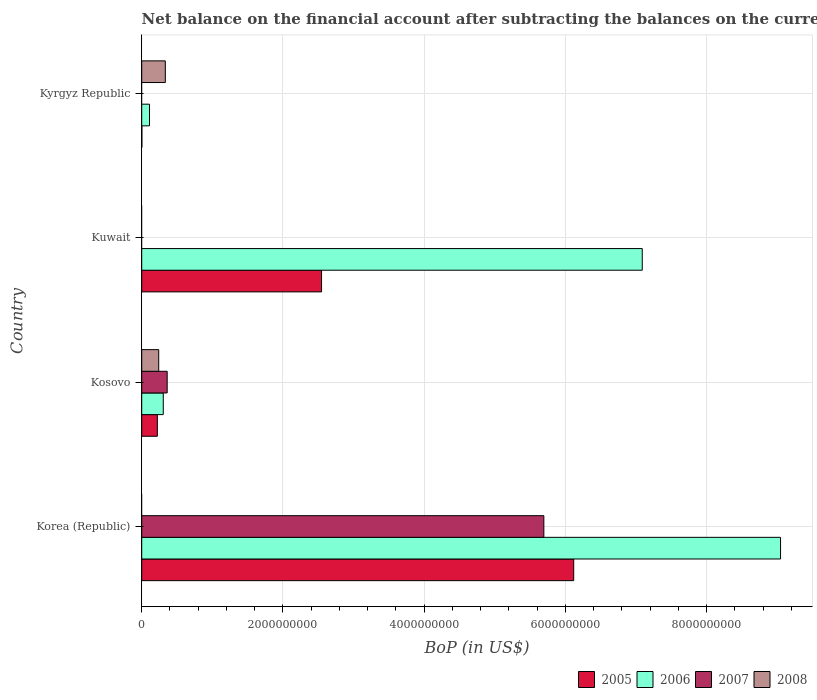Are the number of bars on each tick of the Y-axis equal?
Give a very brief answer. No. How many bars are there on the 3rd tick from the top?
Provide a succinct answer. 4. How many bars are there on the 4th tick from the bottom?
Make the answer very short. 3. What is the label of the 2nd group of bars from the top?
Your response must be concise. Kuwait. In how many cases, is the number of bars for a given country not equal to the number of legend labels?
Provide a succinct answer. 3. Across all countries, what is the maximum Balance of Payments in 2006?
Make the answer very short. 9.05e+09. What is the total Balance of Payments in 2006 in the graph?
Your answer should be compact. 1.65e+1. What is the difference between the Balance of Payments in 2007 in Korea (Republic) and that in Kosovo?
Make the answer very short. 5.33e+09. What is the difference between the Balance of Payments in 2005 in Kosovo and the Balance of Payments in 2006 in Kyrgyz Republic?
Give a very brief answer. 1.11e+08. What is the average Balance of Payments in 2007 per country?
Give a very brief answer. 1.51e+09. What is the difference between the Balance of Payments in 2005 and Balance of Payments in 2007 in Korea (Republic)?
Provide a short and direct response. 4.23e+08. In how many countries, is the Balance of Payments in 2006 greater than 4000000000 US$?
Keep it short and to the point. 2. What is the ratio of the Balance of Payments in 2005 in Kuwait to that in Kyrgyz Republic?
Ensure brevity in your answer.  1201.81. Is the Balance of Payments in 2005 in Kosovo less than that in Kuwait?
Your response must be concise. Yes. What is the difference between the highest and the second highest Balance of Payments in 2006?
Your answer should be very brief. 1.96e+09. What is the difference between the highest and the lowest Balance of Payments in 2005?
Keep it short and to the point. 6.11e+09. How many countries are there in the graph?
Your answer should be compact. 4. Are the values on the major ticks of X-axis written in scientific E-notation?
Keep it short and to the point. No. Does the graph contain any zero values?
Provide a short and direct response. Yes. What is the title of the graph?
Ensure brevity in your answer.  Net balance on the financial account after subtracting the balances on the current accounts. What is the label or title of the X-axis?
Your response must be concise. BoP (in US$). What is the BoP (in US$) of 2005 in Korea (Republic)?
Provide a succinct answer. 6.12e+09. What is the BoP (in US$) of 2006 in Korea (Republic)?
Provide a short and direct response. 9.05e+09. What is the BoP (in US$) in 2007 in Korea (Republic)?
Give a very brief answer. 5.69e+09. What is the BoP (in US$) in 2005 in Kosovo?
Your response must be concise. 2.21e+08. What is the BoP (in US$) of 2006 in Kosovo?
Make the answer very short. 3.05e+08. What is the BoP (in US$) in 2007 in Kosovo?
Your answer should be very brief. 3.60e+08. What is the BoP (in US$) in 2008 in Kosovo?
Offer a very short reply. 2.41e+08. What is the BoP (in US$) in 2005 in Kuwait?
Your response must be concise. 2.55e+09. What is the BoP (in US$) of 2006 in Kuwait?
Keep it short and to the point. 7.09e+09. What is the BoP (in US$) in 2007 in Kuwait?
Offer a terse response. 0. What is the BoP (in US$) in 2005 in Kyrgyz Republic?
Your answer should be very brief. 2.12e+06. What is the BoP (in US$) in 2006 in Kyrgyz Republic?
Ensure brevity in your answer.  1.10e+08. What is the BoP (in US$) in 2008 in Kyrgyz Republic?
Give a very brief answer. 3.34e+08. Across all countries, what is the maximum BoP (in US$) in 2005?
Make the answer very short. 6.12e+09. Across all countries, what is the maximum BoP (in US$) of 2006?
Your response must be concise. 9.05e+09. Across all countries, what is the maximum BoP (in US$) of 2007?
Ensure brevity in your answer.  5.69e+09. Across all countries, what is the maximum BoP (in US$) in 2008?
Your answer should be compact. 3.34e+08. Across all countries, what is the minimum BoP (in US$) of 2005?
Provide a short and direct response. 2.12e+06. Across all countries, what is the minimum BoP (in US$) of 2006?
Your answer should be compact. 1.10e+08. Across all countries, what is the minimum BoP (in US$) in 2007?
Your response must be concise. 0. Across all countries, what is the minimum BoP (in US$) of 2008?
Your answer should be very brief. 0. What is the total BoP (in US$) of 2005 in the graph?
Keep it short and to the point. 8.89e+09. What is the total BoP (in US$) of 2006 in the graph?
Provide a succinct answer. 1.65e+1. What is the total BoP (in US$) in 2007 in the graph?
Your answer should be compact. 6.05e+09. What is the total BoP (in US$) in 2008 in the graph?
Keep it short and to the point. 5.75e+08. What is the difference between the BoP (in US$) in 2005 in Korea (Republic) and that in Kosovo?
Make the answer very short. 5.90e+09. What is the difference between the BoP (in US$) in 2006 in Korea (Republic) and that in Kosovo?
Offer a very short reply. 8.74e+09. What is the difference between the BoP (in US$) of 2007 in Korea (Republic) and that in Kosovo?
Provide a short and direct response. 5.33e+09. What is the difference between the BoP (in US$) of 2005 in Korea (Republic) and that in Kuwait?
Ensure brevity in your answer.  3.57e+09. What is the difference between the BoP (in US$) in 2006 in Korea (Republic) and that in Kuwait?
Provide a succinct answer. 1.96e+09. What is the difference between the BoP (in US$) in 2005 in Korea (Republic) and that in Kyrgyz Republic?
Your response must be concise. 6.11e+09. What is the difference between the BoP (in US$) of 2006 in Korea (Republic) and that in Kyrgyz Republic?
Provide a short and direct response. 8.93e+09. What is the difference between the BoP (in US$) of 2005 in Kosovo and that in Kuwait?
Your answer should be very brief. -2.33e+09. What is the difference between the BoP (in US$) of 2006 in Kosovo and that in Kuwait?
Provide a short and direct response. -6.78e+09. What is the difference between the BoP (in US$) in 2005 in Kosovo and that in Kyrgyz Republic?
Give a very brief answer. 2.19e+08. What is the difference between the BoP (in US$) in 2006 in Kosovo and that in Kyrgyz Republic?
Offer a very short reply. 1.95e+08. What is the difference between the BoP (in US$) in 2008 in Kosovo and that in Kyrgyz Republic?
Ensure brevity in your answer.  -9.37e+07. What is the difference between the BoP (in US$) of 2005 in Kuwait and that in Kyrgyz Republic?
Offer a very short reply. 2.54e+09. What is the difference between the BoP (in US$) of 2006 in Kuwait and that in Kyrgyz Republic?
Offer a terse response. 6.98e+09. What is the difference between the BoP (in US$) of 2005 in Korea (Republic) and the BoP (in US$) of 2006 in Kosovo?
Your answer should be very brief. 5.81e+09. What is the difference between the BoP (in US$) of 2005 in Korea (Republic) and the BoP (in US$) of 2007 in Kosovo?
Give a very brief answer. 5.76e+09. What is the difference between the BoP (in US$) in 2005 in Korea (Republic) and the BoP (in US$) in 2008 in Kosovo?
Your response must be concise. 5.88e+09. What is the difference between the BoP (in US$) in 2006 in Korea (Republic) and the BoP (in US$) in 2007 in Kosovo?
Make the answer very short. 8.68e+09. What is the difference between the BoP (in US$) in 2006 in Korea (Republic) and the BoP (in US$) in 2008 in Kosovo?
Provide a short and direct response. 8.80e+09. What is the difference between the BoP (in US$) in 2007 in Korea (Republic) and the BoP (in US$) in 2008 in Kosovo?
Keep it short and to the point. 5.45e+09. What is the difference between the BoP (in US$) in 2005 in Korea (Republic) and the BoP (in US$) in 2006 in Kuwait?
Give a very brief answer. -9.71e+08. What is the difference between the BoP (in US$) in 2005 in Korea (Republic) and the BoP (in US$) in 2006 in Kyrgyz Republic?
Give a very brief answer. 6.01e+09. What is the difference between the BoP (in US$) of 2005 in Korea (Republic) and the BoP (in US$) of 2008 in Kyrgyz Republic?
Provide a succinct answer. 5.78e+09. What is the difference between the BoP (in US$) of 2006 in Korea (Republic) and the BoP (in US$) of 2008 in Kyrgyz Republic?
Your answer should be compact. 8.71e+09. What is the difference between the BoP (in US$) in 2007 in Korea (Republic) and the BoP (in US$) in 2008 in Kyrgyz Republic?
Offer a terse response. 5.36e+09. What is the difference between the BoP (in US$) of 2005 in Kosovo and the BoP (in US$) of 2006 in Kuwait?
Keep it short and to the point. -6.87e+09. What is the difference between the BoP (in US$) of 2005 in Kosovo and the BoP (in US$) of 2006 in Kyrgyz Republic?
Provide a short and direct response. 1.11e+08. What is the difference between the BoP (in US$) in 2005 in Kosovo and the BoP (in US$) in 2008 in Kyrgyz Republic?
Offer a terse response. -1.13e+08. What is the difference between the BoP (in US$) of 2006 in Kosovo and the BoP (in US$) of 2008 in Kyrgyz Republic?
Give a very brief answer. -2.94e+07. What is the difference between the BoP (in US$) in 2007 in Kosovo and the BoP (in US$) in 2008 in Kyrgyz Republic?
Offer a terse response. 2.61e+07. What is the difference between the BoP (in US$) of 2005 in Kuwait and the BoP (in US$) of 2006 in Kyrgyz Republic?
Your answer should be compact. 2.44e+09. What is the difference between the BoP (in US$) of 2005 in Kuwait and the BoP (in US$) of 2008 in Kyrgyz Republic?
Provide a short and direct response. 2.21e+09. What is the difference between the BoP (in US$) of 2006 in Kuwait and the BoP (in US$) of 2008 in Kyrgyz Republic?
Give a very brief answer. 6.75e+09. What is the average BoP (in US$) of 2005 per country?
Give a very brief answer. 2.22e+09. What is the average BoP (in US$) in 2006 per country?
Provide a succinct answer. 4.14e+09. What is the average BoP (in US$) of 2007 per country?
Provide a succinct answer. 1.51e+09. What is the average BoP (in US$) in 2008 per country?
Your answer should be compact. 1.44e+08. What is the difference between the BoP (in US$) in 2005 and BoP (in US$) in 2006 in Korea (Republic)?
Provide a short and direct response. -2.93e+09. What is the difference between the BoP (in US$) in 2005 and BoP (in US$) in 2007 in Korea (Republic)?
Offer a very short reply. 4.23e+08. What is the difference between the BoP (in US$) of 2006 and BoP (in US$) of 2007 in Korea (Republic)?
Provide a short and direct response. 3.35e+09. What is the difference between the BoP (in US$) in 2005 and BoP (in US$) in 2006 in Kosovo?
Offer a terse response. -8.37e+07. What is the difference between the BoP (in US$) in 2005 and BoP (in US$) in 2007 in Kosovo?
Provide a succinct answer. -1.39e+08. What is the difference between the BoP (in US$) in 2005 and BoP (in US$) in 2008 in Kosovo?
Make the answer very short. -1.93e+07. What is the difference between the BoP (in US$) of 2006 and BoP (in US$) of 2007 in Kosovo?
Give a very brief answer. -5.55e+07. What is the difference between the BoP (in US$) of 2006 and BoP (in US$) of 2008 in Kosovo?
Keep it short and to the point. 6.44e+07. What is the difference between the BoP (in US$) in 2007 and BoP (in US$) in 2008 in Kosovo?
Ensure brevity in your answer.  1.20e+08. What is the difference between the BoP (in US$) of 2005 and BoP (in US$) of 2006 in Kuwait?
Offer a very short reply. -4.54e+09. What is the difference between the BoP (in US$) of 2005 and BoP (in US$) of 2006 in Kyrgyz Republic?
Your response must be concise. -1.08e+08. What is the difference between the BoP (in US$) in 2005 and BoP (in US$) in 2008 in Kyrgyz Republic?
Give a very brief answer. -3.32e+08. What is the difference between the BoP (in US$) in 2006 and BoP (in US$) in 2008 in Kyrgyz Republic?
Your answer should be very brief. -2.24e+08. What is the ratio of the BoP (in US$) in 2005 in Korea (Republic) to that in Kosovo?
Give a very brief answer. 27.65. What is the ratio of the BoP (in US$) in 2006 in Korea (Republic) to that in Kosovo?
Keep it short and to the point. 29.66. What is the ratio of the BoP (in US$) of 2007 in Korea (Republic) to that in Kosovo?
Make the answer very short. 15.8. What is the ratio of the BoP (in US$) of 2005 in Korea (Republic) to that in Kuwait?
Provide a short and direct response. 2.4. What is the ratio of the BoP (in US$) of 2006 in Korea (Republic) to that in Kuwait?
Your answer should be compact. 1.28. What is the ratio of the BoP (in US$) of 2005 in Korea (Republic) to that in Kyrgyz Republic?
Offer a terse response. 2886.94. What is the ratio of the BoP (in US$) of 2006 in Korea (Republic) to that in Kyrgyz Republic?
Your answer should be compact. 81.93. What is the ratio of the BoP (in US$) in 2005 in Kosovo to that in Kuwait?
Make the answer very short. 0.09. What is the ratio of the BoP (in US$) of 2006 in Kosovo to that in Kuwait?
Keep it short and to the point. 0.04. What is the ratio of the BoP (in US$) in 2005 in Kosovo to that in Kyrgyz Republic?
Your answer should be very brief. 104.42. What is the ratio of the BoP (in US$) in 2006 in Kosovo to that in Kyrgyz Republic?
Provide a short and direct response. 2.76. What is the ratio of the BoP (in US$) of 2008 in Kosovo to that in Kyrgyz Republic?
Offer a terse response. 0.72. What is the ratio of the BoP (in US$) of 2005 in Kuwait to that in Kyrgyz Republic?
Your answer should be very brief. 1201.81. What is the ratio of the BoP (in US$) of 2006 in Kuwait to that in Kyrgyz Republic?
Ensure brevity in your answer.  64.19. What is the difference between the highest and the second highest BoP (in US$) in 2005?
Your answer should be very brief. 3.57e+09. What is the difference between the highest and the second highest BoP (in US$) of 2006?
Make the answer very short. 1.96e+09. What is the difference between the highest and the lowest BoP (in US$) in 2005?
Your answer should be very brief. 6.11e+09. What is the difference between the highest and the lowest BoP (in US$) in 2006?
Offer a terse response. 8.93e+09. What is the difference between the highest and the lowest BoP (in US$) in 2007?
Your answer should be very brief. 5.69e+09. What is the difference between the highest and the lowest BoP (in US$) in 2008?
Provide a short and direct response. 3.34e+08. 